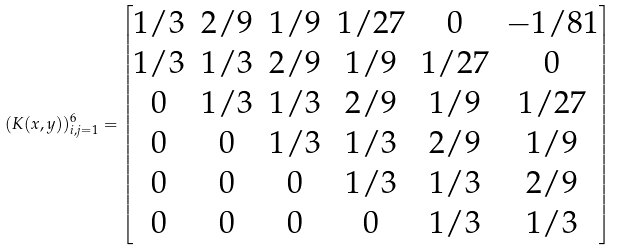Convert formula to latex. <formula><loc_0><loc_0><loc_500><loc_500>( K ( x , y ) ) _ { i , j = 1 } ^ { 6 } = \begin{bmatrix} 1 / 3 & 2 / 9 & 1 / 9 & 1 / 2 7 & 0 & - 1 / 8 1 \\ 1 / 3 & 1 / 3 & 2 / 9 & 1 / 9 & 1 / 2 7 & 0 \\ 0 & 1 / 3 & 1 / 3 & 2 / 9 & 1 / 9 & 1 / 2 7 \\ 0 & 0 & 1 / 3 & 1 / 3 & 2 / 9 & 1 / 9 \\ 0 & 0 & 0 & 1 / 3 & 1 / 3 & 2 / 9 \\ 0 & 0 & 0 & 0 & 1 / 3 & 1 / 3 \end{bmatrix}</formula> 